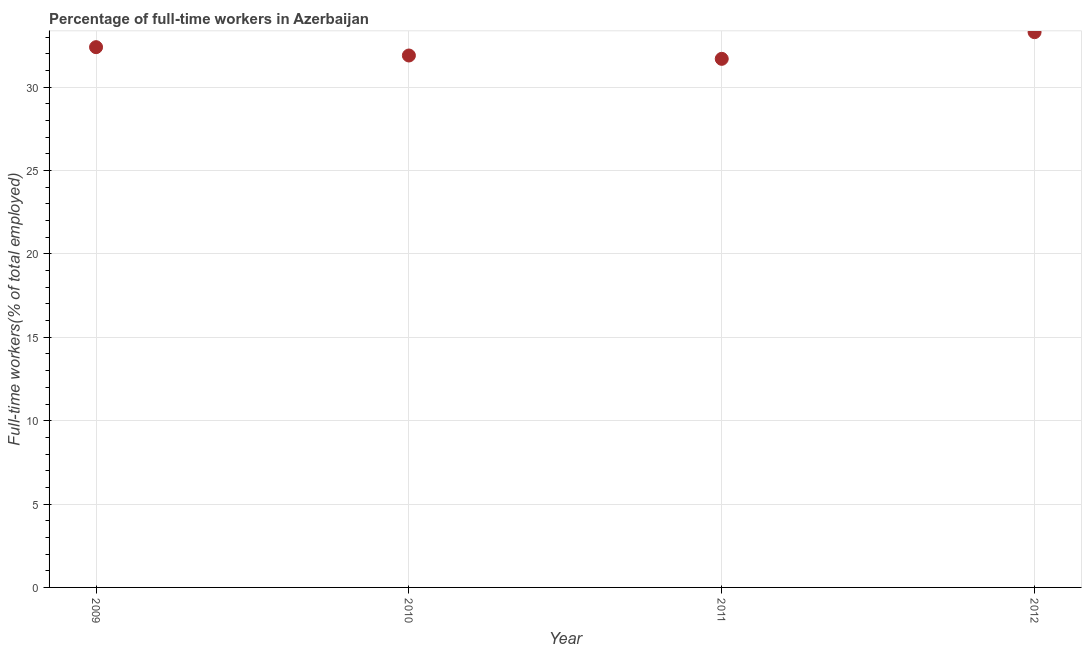What is the percentage of full-time workers in 2010?
Give a very brief answer. 31.9. Across all years, what is the maximum percentage of full-time workers?
Your response must be concise. 33.3. Across all years, what is the minimum percentage of full-time workers?
Offer a terse response. 31.7. In which year was the percentage of full-time workers maximum?
Offer a very short reply. 2012. What is the sum of the percentage of full-time workers?
Give a very brief answer. 129.3. What is the difference between the percentage of full-time workers in 2009 and 2011?
Make the answer very short. 0.7. What is the average percentage of full-time workers per year?
Make the answer very short. 32.33. What is the median percentage of full-time workers?
Make the answer very short. 32.15. Do a majority of the years between 2009 and 2010 (inclusive) have percentage of full-time workers greater than 32 %?
Provide a succinct answer. No. What is the ratio of the percentage of full-time workers in 2010 to that in 2011?
Offer a terse response. 1.01. Is the percentage of full-time workers in 2009 less than that in 2012?
Give a very brief answer. Yes. What is the difference between the highest and the second highest percentage of full-time workers?
Your response must be concise. 0.9. What is the difference between the highest and the lowest percentage of full-time workers?
Provide a short and direct response. 1.6. In how many years, is the percentage of full-time workers greater than the average percentage of full-time workers taken over all years?
Keep it short and to the point. 2. How many dotlines are there?
Your answer should be very brief. 1. How many years are there in the graph?
Make the answer very short. 4. What is the difference between two consecutive major ticks on the Y-axis?
Make the answer very short. 5. Are the values on the major ticks of Y-axis written in scientific E-notation?
Provide a succinct answer. No. Does the graph contain any zero values?
Offer a terse response. No. What is the title of the graph?
Provide a short and direct response. Percentage of full-time workers in Azerbaijan. What is the label or title of the X-axis?
Provide a succinct answer. Year. What is the label or title of the Y-axis?
Offer a very short reply. Full-time workers(% of total employed). What is the Full-time workers(% of total employed) in 2009?
Keep it short and to the point. 32.4. What is the Full-time workers(% of total employed) in 2010?
Your answer should be compact. 31.9. What is the Full-time workers(% of total employed) in 2011?
Keep it short and to the point. 31.7. What is the Full-time workers(% of total employed) in 2012?
Keep it short and to the point. 33.3. What is the difference between the Full-time workers(% of total employed) in 2009 and 2010?
Offer a terse response. 0.5. What is the difference between the Full-time workers(% of total employed) in 2009 and 2012?
Your answer should be compact. -0.9. What is the difference between the Full-time workers(% of total employed) in 2011 and 2012?
Offer a very short reply. -1.6. What is the ratio of the Full-time workers(% of total employed) in 2010 to that in 2011?
Keep it short and to the point. 1.01. What is the ratio of the Full-time workers(% of total employed) in 2010 to that in 2012?
Give a very brief answer. 0.96. What is the ratio of the Full-time workers(% of total employed) in 2011 to that in 2012?
Your answer should be very brief. 0.95. 